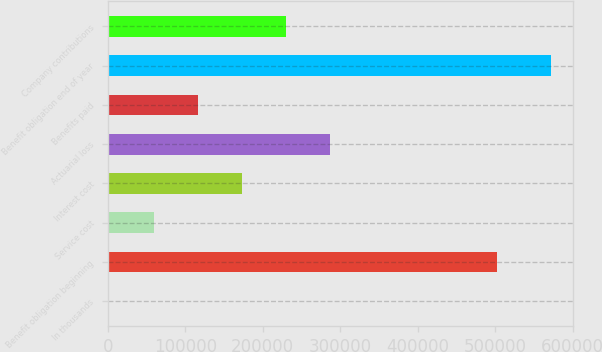Convert chart. <chart><loc_0><loc_0><loc_500><loc_500><bar_chart><fcel>In thousands<fcel>Benefit obligation beginning<fcel>Service cost<fcel>Interest cost<fcel>Actuarial loss<fcel>Benefits paid<fcel>Benefit obligation end of year<fcel>Company contributions<nl><fcel>2011<fcel>502657<fcel>59016.7<fcel>173028<fcel>287040<fcel>116022<fcel>572068<fcel>230034<nl></chart> 